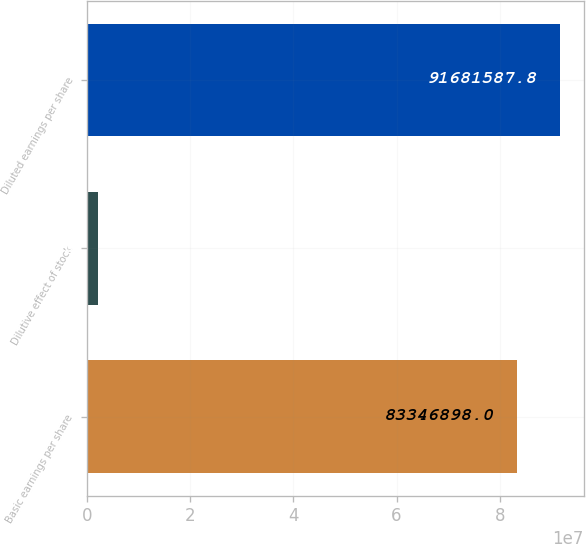Convert chart. <chart><loc_0><loc_0><loc_500><loc_500><bar_chart><fcel>Basic earnings per share<fcel>Dilutive effect of stock<fcel>Diluted earnings per share<nl><fcel>8.33469e+07<fcel>2.05882e+06<fcel>9.16816e+07<nl></chart> 